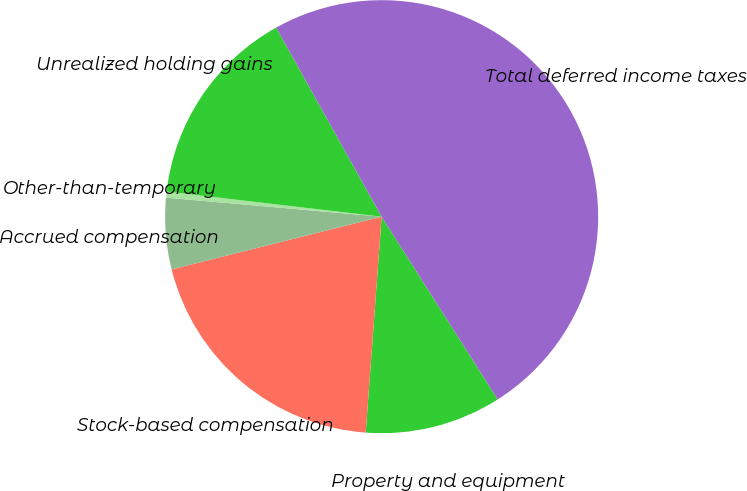Convert chart. <chart><loc_0><loc_0><loc_500><loc_500><pie_chart><fcel>Property and equipment<fcel>Stock-based compensation<fcel>Accrued compensation<fcel>Other-than-temporary<fcel>Unrealized holding gains<fcel>Total deferred income taxes<nl><fcel>10.18%<fcel>19.91%<fcel>5.32%<fcel>0.45%<fcel>15.05%<fcel>49.09%<nl></chart> 